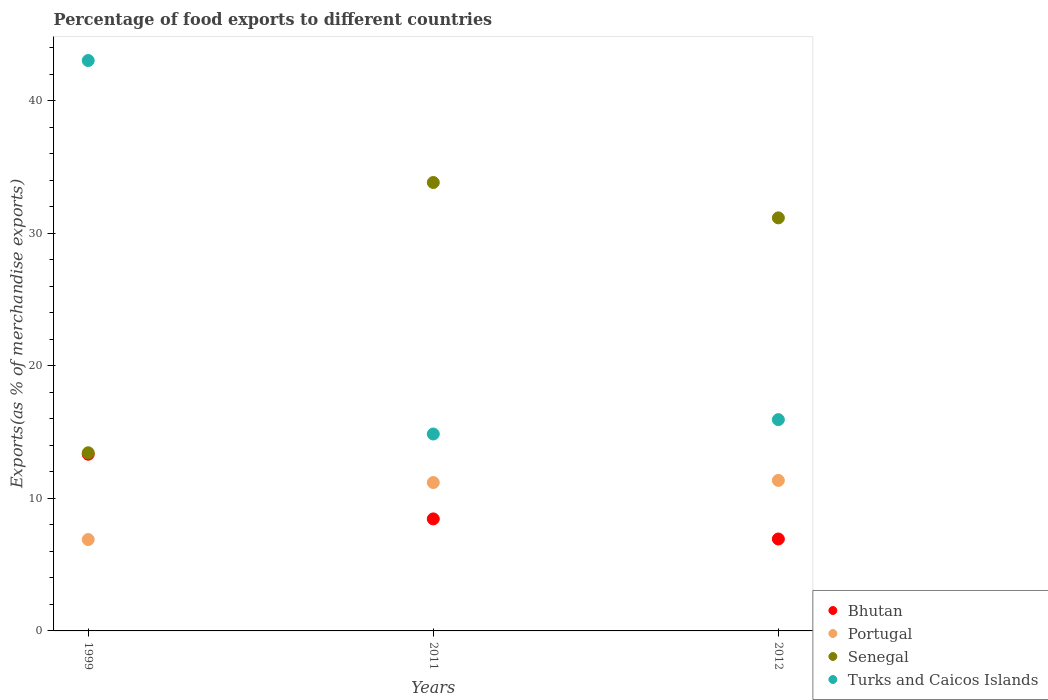How many different coloured dotlines are there?
Give a very brief answer. 4. Is the number of dotlines equal to the number of legend labels?
Keep it short and to the point. Yes. What is the percentage of exports to different countries in Senegal in 1999?
Offer a terse response. 13.44. Across all years, what is the maximum percentage of exports to different countries in Turks and Caicos Islands?
Your answer should be compact. 43.04. Across all years, what is the minimum percentage of exports to different countries in Portugal?
Give a very brief answer. 6.89. In which year was the percentage of exports to different countries in Turks and Caicos Islands maximum?
Offer a very short reply. 1999. What is the total percentage of exports to different countries in Turks and Caicos Islands in the graph?
Give a very brief answer. 73.84. What is the difference between the percentage of exports to different countries in Bhutan in 2011 and that in 2012?
Provide a short and direct response. 1.52. What is the difference between the percentage of exports to different countries in Turks and Caicos Islands in 2011 and the percentage of exports to different countries in Portugal in 1999?
Offer a very short reply. 7.96. What is the average percentage of exports to different countries in Senegal per year?
Keep it short and to the point. 26.15. In the year 2011, what is the difference between the percentage of exports to different countries in Portugal and percentage of exports to different countries in Turks and Caicos Islands?
Your answer should be compact. -3.66. What is the ratio of the percentage of exports to different countries in Bhutan in 2011 to that in 2012?
Your answer should be compact. 1.22. What is the difference between the highest and the second highest percentage of exports to different countries in Turks and Caicos Islands?
Your answer should be very brief. 27.1. What is the difference between the highest and the lowest percentage of exports to different countries in Senegal?
Provide a succinct answer. 20.39. In how many years, is the percentage of exports to different countries in Bhutan greater than the average percentage of exports to different countries in Bhutan taken over all years?
Keep it short and to the point. 1. Is it the case that in every year, the sum of the percentage of exports to different countries in Portugal and percentage of exports to different countries in Senegal  is greater than the sum of percentage of exports to different countries in Turks and Caicos Islands and percentage of exports to different countries in Bhutan?
Your answer should be compact. No. Does the percentage of exports to different countries in Portugal monotonically increase over the years?
Make the answer very short. Yes. Is the percentage of exports to different countries in Bhutan strictly less than the percentage of exports to different countries in Turks and Caicos Islands over the years?
Your answer should be compact. Yes. How many dotlines are there?
Keep it short and to the point. 4. How many years are there in the graph?
Your response must be concise. 3. What is the difference between two consecutive major ticks on the Y-axis?
Make the answer very short. 10. Does the graph contain grids?
Provide a succinct answer. No. Where does the legend appear in the graph?
Your response must be concise. Bottom right. What is the title of the graph?
Offer a very short reply. Percentage of food exports to different countries. Does "Europe(developing only)" appear as one of the legend labels in the graph?
Your answer should be very brief. No. What is the label or title of the X-axis?
Offer a very short reply. Years. What is the label or title of the Y-axis?
Make the answer very short. Exports(as % of merchandise exports). What is the Exports(as % of merchandise exports) in Bhutan in 1999?
Provide a short and direct response. 13.33. What is the Exports(as % of merchandise exports) of Portugal in 1999?
Keep it short and to the point. 6.89. What is the Exports(as % of merchandise exports) in Senegal in 1999?
Your response must be concise. 13.44. What is the Exports(as % of merchandise exports) of Turks and Caicos Islands in 1999?
Keep it short and to the point. 43.04. What is the Exports(as % of merchandise exports) of Bhutan in 2011?
Give a very brief answer. 8.45. What is the Exports(as % of merchandise exports) of Portugal in 2011?
Ensure brevity in your answer.  11.2. What is the Exports(as % of merchandise exports) in Senegal in 2011?
Your answer should be compact. 33.84. What is the Exports(as % of merchandise exports) of Turks and Caicos Islands in 2011?
Ensure brevity in your answer.  14.86. What is the Exports(as % of merchandise exports) in Bhutan in 2012?
Make the answer very short. 6.94. What is the Exports(as % of merchandise exports) of Portugal in 2012?
Offer a very short reply. 11.36. What is the Exports(as % of merchandise exports) in Senegal in 2012?
Ensure brevity in your answer.  31.17. What is the Exports(as % of merchandise exports) of Turks and Caicos Islands in 2012?
Provide a short and direct response. 15.94. Across all years, what is the maximum Exports(as % of merchandise exports) in Bhutan?
Provide a succinct answer. 13.33. Across all years, what is the maximum Exports(as % of merchandise exports) in Portugal?
Your answer should be very brief. 11.36. Across all years, what is the maximum Exports(as % of merchandise exports) in Senegal?
Give a very brief answer. 33.84. Across all years, what is the maximum Exports(as % of merchandise exports) of Turks and Caicos Islands?
Make the answer very short. 43.04. Across all years, what is the minimum Exports(as % of merchandise exports) of Bhutan?
Your answer should be very brief. 6.94. Across all years, what is the minimum Exports(as % of merchandise exports) of Portugal?
Offer a very short reply. 6.89. Across all years, what is the minimum Exports(as % of merchandise exports) of Senegal?
Your answer should be very brief. 13.44. Across all years, what is the minimum Exports(as % of merchandise exports) of Turks and Caicos Islands?
Your answer should be compact. 14.86. What is the total Exports(as % of merchandise exports) of Bhutan in the graph?
Ensure brevity in your answer.  28.72. What is the total Exports(as % of merchandise exports) of Portugal in the graph?
Provide a succinct answer. 29.45. What is the total Exports(as % of merchandise exports) of Senegal in the graph?
Keep it short and to the point. 78.45. What is the total Exports(as % of merchandise exports) in Turks and Caicos Islands in the graph?
Ensure brevity in your answer.  73.84. What is the difference between the Exports(as % of merchandise exports) in Bhutan in 1999 and that in 2011?
Provide a succinct answer. 4.88. What is the difference between the Exports(as % of merchandise exports) in Portugal in 1999 and that in 2011?
Your response must be concise. -4.3. What is the difference between the Exports(as % of merchandise exports) in Senegal in 1999 and that in 2011?
Ensure brevity in your answer.  -20.39. What is the difference between the Exports(as % of merchandise exports) of Turks and Caicos Islands in 1999 and that in 2011?
Offer a terse response. 28.18. What is the difference between the Exports(as % of merchandise exports) of Bhutan in 1999 and that in 2012?
Ensure brevity in your answer.  6.4. What is the difference between the Exports(as % of merchandise exports) of Portugal in 1999 and that in 2012?
Offer a very short reply. -4.46. What is the difference between the Exports(as % of merchandise exports) of Senegal in 1999 and that in 2012?
Offer a very short reply. -17.72. What is the difference between the Exports(as % of merchandise exports) of Turks and Caicos Islands in 1999 and that in 2012?
Your response must be concise. 27.1. What is the difference between the Exports(as % of merchandise exports) in Bhutan in 2011 and that in 2012?
Your answer should be compact. 1.52. What is the difference between the Exports(as % of merchandise exports) of Portugal in 2011 and that in 2012?
Offer a very short reply. -0.16. What is the difference between the Exports(as % of merchandise exports) in Senegal in 2011 and that in 2012?
Offer a terse response. 2.67. What is the difference between the Exports(as % of merchandise exports) of Turks and Caicos Islands in 2011 and that in 2012?
Your answer should be compact. -1.08. What is the difference between the Exports(as % of merchandise exports) of Bhutan in 1999 and the Exports(as % of merchandise exports) of Portugal in 2011?
Your response must be concise. 2.13. What is the difference between the Exports(as % of merchandise exports) in Bhutan in 1999 and the Exports(as % of merchandise exports) in Senegal in 2011?
Make the answer very short. -20.5. What is the difference between the Exports(as % of merchandise exports) of Bhutan in 1999 and the Exports(as % of merchandise exports) of Turks and Caicos Islands in 2011?
Offer a very short reply. -1.53. What is the difference between the Exports(as % of merchandise exports) of Portugal in 1999 and the Exports(as % of merchandise exports) of Senegal in 2011?
Offer a terse response. -26.94. What is the difference between the Exports(as % of merchandise exports) of Portugal in 1999 and the Exports(as % of merchandise exports) of Turks and Caicos Islands in 2011?
Provide a short and direct response. -7.96. What is the difference between the Exports(as % of merchandise exports) in Senegal in 1999 and the Exports(as % of merchandise exports) in Turks and Caicos Islands in 2011?
Make the answer very short. -1.42. What is the difference between the Exports(as % of merchandise exports) of Bhutan in 1999 and the Exports(as % of merchandise exports) of Portugal in 2012?
Provide a succinct answer. 1.97. What is the difference between the Exports(as % of merchandise exports) in Bhutan in 1999 and the Exports(as % of merchandise exports) in Senegal in 2012?
Give a very brief answer. -17.84. What is the difference between the Exports(as % of merchandise exports) of Bhutan in 1999 and the Exports(as % of merchandise exports) of Turks and Caicos Islands in 2012?
Provide a short and direct response. -2.61. What is the difference between the Exports(as % of merchandise exports) of Portugal in 1999 and the Exports(as % of merchandise exports) of Senegal in 2012?
Offer a very short reply. -24.27. What is the difference between the Exports(as % of merchandise exports) of Portugal in 1999 and the Exports(as % of merchandise exports) of Turks and Caicos Islands in 2012?
Offer a terse response. -9.05. What is the difference between the Exports(as % of merchandise exports) of Senegal in 1999 and the Exports(as % of merchandise exports) of Turks and Caicos Islands in 2012?
Offer a very short reply. -2.5. What is the difference between the Exports(as % of merchandise exports) of Bhutan in 2011 and the Exports(as % of merchandise exports) of Portugal in 2012?
Offer a terse response. -2.91. What is the difference between the Exports(as % of merchandise exports) of Bhutan in 2011 and the Exports(as % of merchandise exports) of Senegal in 2012?
Make the answer very short. -22.71. What is the difference between the Exports(as % of merchandise exports) of Bhutan in 2011 and the Exports(as % of merchandise exports) of Turks and Caicos Islands in 2012?
Provide a succinct answer. -7.49. What is the difference between the Exports(as % of merchandise exports) in Portugal in 2011 and the Exports(as % of merchandise exports) in Senegal in 2012?
Keep it short and to the point. -19.97. What is the difference between the Exports(as % of merchandise exports) of Portugal in 2011 and the Exports(as % of merchandise exports) of Turks and Caicos Islands in 2012?
Your answer should be very brief. -4.74. What is the difference between the Exports(as % of merchandise exports) of Senegal in 2011 and the Exports(as % of merchandise exports) of Turks and Caicos Islands in 2012?
Your answer should be very brief. 17.89. What is the average Exports(as % of merchandise exports) in Bhutan per year?
Keep it short and to the point. 9.57. What is the average Exports(as % of merchandise exports) of Portugal per year?
Your response must be concise. 9.82. What is the average Exports(as % of merchandise exports) of Senegal per year?
Your response must be concise. 26.15. What is the average Exports(as % of merchandise exports) in Turks and Caicos Islands per year?
Your response must be concise. 24.61. In the year 1999, what is the difference between the Exports(as % of merchandise exports) of Bhutan and Exports(as % of merchandise exports) of Portugal?
Provide a short and direct response. 6.44. In the year 1999, what is the difference between the Exports(as % of merchandise exports) in Bhutan and Exports(as % of merchandise exports) in Senegal?
Provide a succinct answer. -0.11. In the year 1999, what is the difference between the Exports(as % of merchandise exports) in Bhutan and Exports(as % of merchandise exports) in Turks and Caicos Islands?
Your response must be concise. -29.71. In the year 1999, what is the difference between the Exports(as % of merchandise exports) of Portugal and Exports(as % of merchandise exports) of Senegal?
Your answer should be compact. -6.55. In the year 1999, what is the difference between the Exports(as % of merchandise exports) of Portugal and Exports(as % of merchandise exports) of Turks and Caicos Islands?
Offer a terse response. -36.15. In the year 1999, what is the difference between the Exports(as % of merchandise exports) of Senegal and Exports(as % of merchandise exports) of Turks and Caicos Islands?
Make the answer very short. -29.6. In the year 2011, what is the difference between the Exports(as % of merchandise exports) of Bhutan and Exports(as % of merchandise exports) of Portugal?
Your answer should be very brief. -2.74. In the year 2011, what is the difference between the Exports(as % of merchandise exports) in Bhutan and Exports(as % of merchandise exports) in Senegal?
Provide a short and direct response. -25.38. In the year 2011, what is the difference between the Exports(as % of merchandise exports) of Bhutan and Exports(as % of merchandise exports) of Turks and Caicos Islands?
Your response must be concise. -6.41. In the year 2011, what is the difference between the Exports(as % of merchandise exports) of Portugal and Exports(as % of merchandise exports) of Senegal?
Give a very brief answer. -22.64. In the year 2011, what is the difference between the Exports(as % of merchandise exports) of Portugal and Exports(as % of merchandise exports) of Turks and Caicos Islands?
Your response must be concise. -3.66. In the year 2011, what is the difference between the Exports(as % of merchandise exports) in Senegal and Exports(as % of merchandise exports) in Turks and Caicos Islands?
Ensure brevity in your answer.  18.98. In the year 2012, what is the difference between the Exports(as % of merchandise exports) of Bhutan and Exports(as % of merchandise exports) of Portugal?
Make the answer very short. -4.42. In the year 2012, what is the difference between the Exports(as % of merchandise exports) of Bhutan and Exports(as % of merchandise exports) of Senegal?
Make the answer very short. -24.23. In the year 2012, what is the difference between the Exports(as % of merchandise exports) in Bhutan and Exports(as % of merchandise exports) in Turks and Caicos Islands?
Provide a succinct answer. -9.01. In the year 2012, what is the difference between the Exports(as % of merchandise exports) in Portugal and Exports(as % of merchandise exports) in Senegal?
Give a very brief answer. -19.81. In the year 2012, what is the difference between the Exports(as % of merchandise exports) of Portugal and Exports(as % of merchandise exports) of Turks and Caicos Islands?
Make the answer very short. -4.58. In the year 2012, what is the difference between the Exports(as % of merchandise exports) of Senegal and Exports(as % of merchandise exports) of Turks and Caicos Islands?
Your response must be concise. 15.23. What is the ratio of the Exports(as % of merchandise exports) in Bhutan in 1999 to that in 2011?
Ensure brevity in your answer.  1.58. What is the ratio of the Exports(as % of merchandise exports) in Portugal in 1999 to that in 2011?
Provide a succinct answer. 0.62. What is the ratio of the Exports(as % of merchandise exports) in Senegal in 1999 to that in 2011?
Offer a very short reply. 0.4. What is the ratio of the Exports(as % of merchandise exports) in Turks and Caicos Islands in 1999 to that in 2011?
Provide a short and direct response. 2.9. What is the ratio of the Exports(as % of merchandise exports) in Bhutan in 1999 to that in 2012?
Your answer should be compact. 1.92. What is the ratio of the Exports(as % of merchandise exports) in Portugal in 1999 to that in 2012?
Give a very brief answer. 0.61. What is the ratio of the Exports(as % of merchandise exports) in Senegal in 1999 to that in 2012?
Offer a terse response. 0.43. What is the ratio of the Exports(as % of merchandise exports) of Turks and Caicos Islands in 1999 to that in 2012?
Offer a very short reply. 2.7. What is the ratio of the Exports(as % of merchandise exports) in Bhutan in 2011 to that in 2012?
Your answer should be very brief. 1.22. What is the ratio of the Exports(as % of merchandise exports) in Portugal in 2011 to that in 2012?
Offer a terse response. 0.99. What is the ratio of the Exports(as % of merchandise exports) in Senegal in 2011 to that in 2012?
Provide a succinct answer. 1.09. What is the ratio of the Exports(as % of merchandise exports) of Turks and Caicos Islands in 2011 to that in 2012?
Your answer should be very brief. 0.93. What is the difference between the highest and the second highest Exports(as % of merchandise exports) of Bhutan?
Keep it short and to the point. 4.88. What is the difference between the highest and the second highest Exports(as % of merchandise exports) of Portugal?
Ensure brevity in your answer.  0.16. What is the difference between the highest and the second highest Exports(as % of merchandise exports) in Senegal?
Provide a short and direct response. 2.67. What is the difference between the highest and the second highest Exports(as % of merchandise exports) of Turks and Caicos Islands?
Offer a very short reply. 27.1. What is the difference between the highest and the lowest Exports(as % of merchandise exports) in Bhutan?
Keep it short and to the point. 6.4. What is the difference between the highest and the lowest Exports(as % of merchandise exports) of Portugal?
Provide a succinct answer. 4.46. What is the difference between the highest and the lowest Exports(as % of merchandise exports) of Senegal?
Ensure brevity in your answer.  20.39. What is the difference between the highest and the lowest Exports(as % of merchandise exports) of Turks and Caicos Islands?
Offer a very short reply. 28.18. 